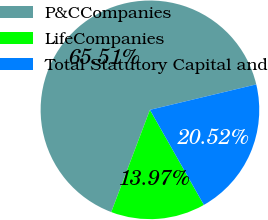Convert chart to OTSL. <chart><loc_0><loc_0><loc_500><loc_500><pie_chart><fcel>P&CCompanies<fcel>LifeCompanies<fcel>Total Statutory Capital and<nl><fcel>65.5%<fcel>13.97%<fcel>20.52%<nl></chart> 